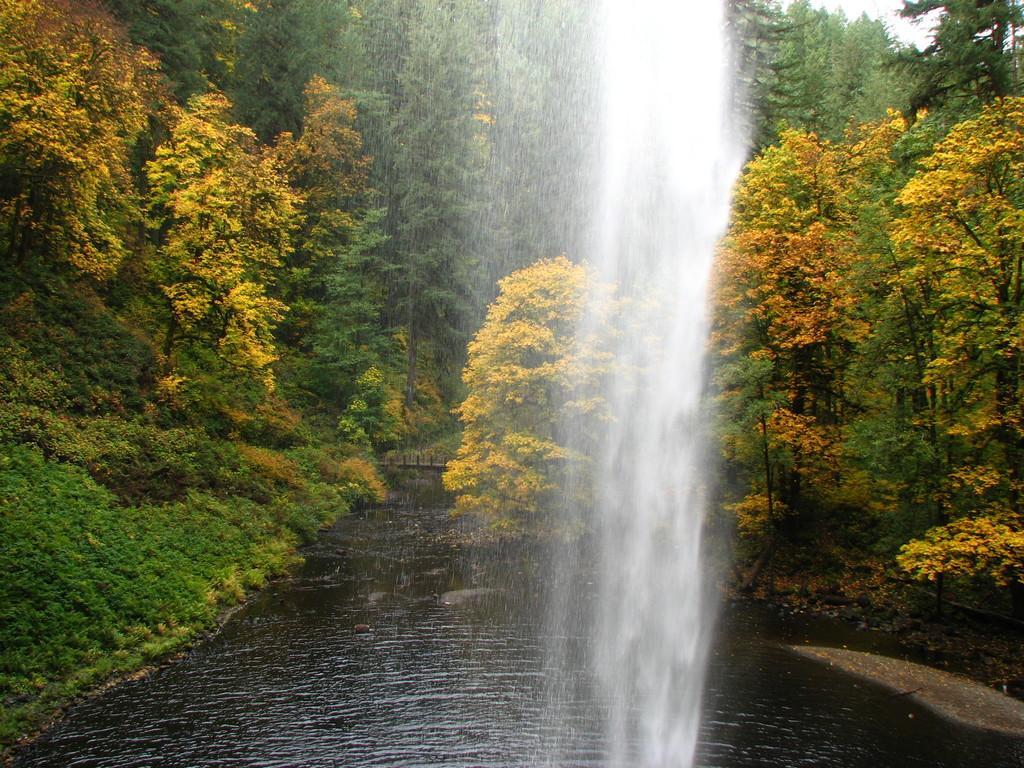Can you describe this image briefly? In this picture we can see waterfall. In the background we can see many trees. At the bottom there is a water. In the top right corner there is a sky. 